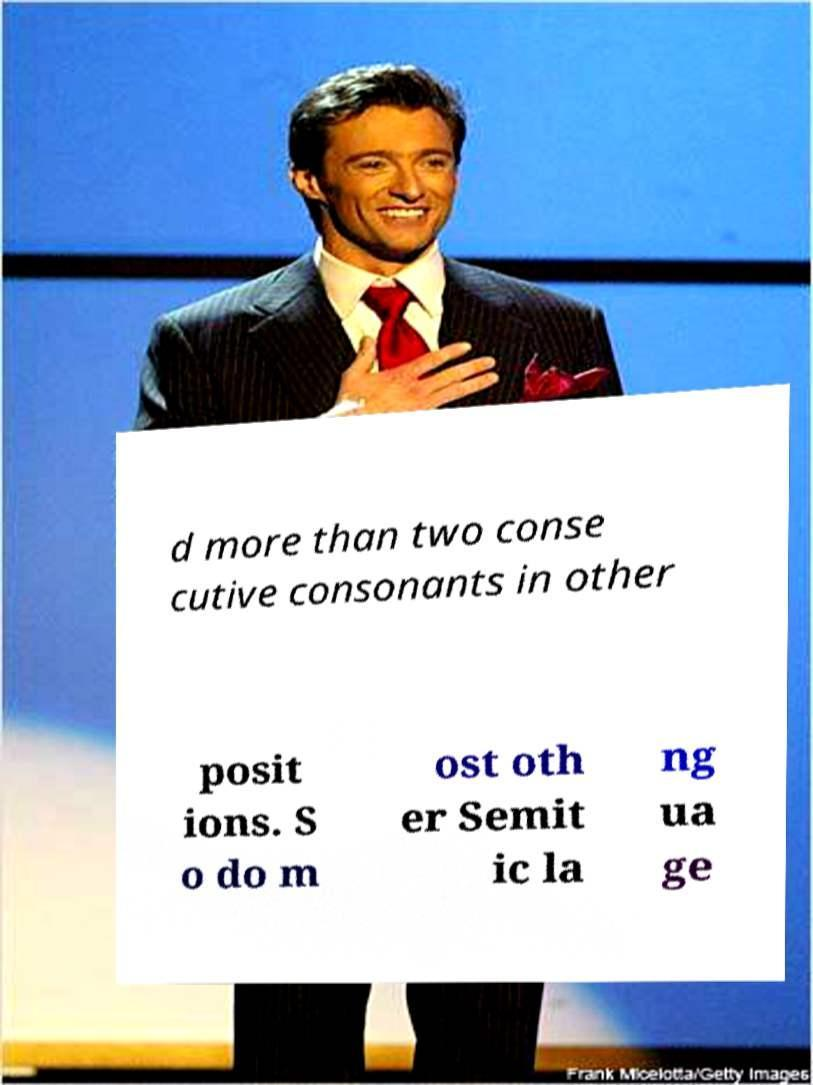Please identify and transcribe the text found in this image. d more than two conse cutive consonants in other posit ions. S o do m ost oth er Semit ic la ng ua ge 